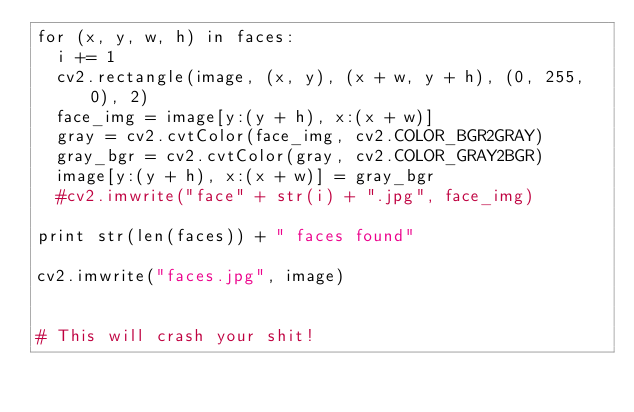Convert code to text. <code><loc_0><loc_0><loc_500><loc_500><_Python_>for (x, y, w, h) in faces:
  i += 1
  cv2.rectangle(image, (x, y), (x + w, y + h), (0, 255, 0), 2)
  face_img = image[y:(y + h), x:(x + w)]
  gray = cv2.cvtColor(face_img, cv2.COLOR_BGR2GRAY)
  gray_bgr = cv2.cvtColor(gray, cv2.COLOR_GRAY2BGR)
  image[y:(y + h), x:(x + w)] = gray_bgr
  #cv2.imwrite("face" + str(i) + ".jpg", face_img)

print str(len(faces)) + " faces found"

cv2.imwrite("faces.jpg", image)


# This will crash your shit!</code> 